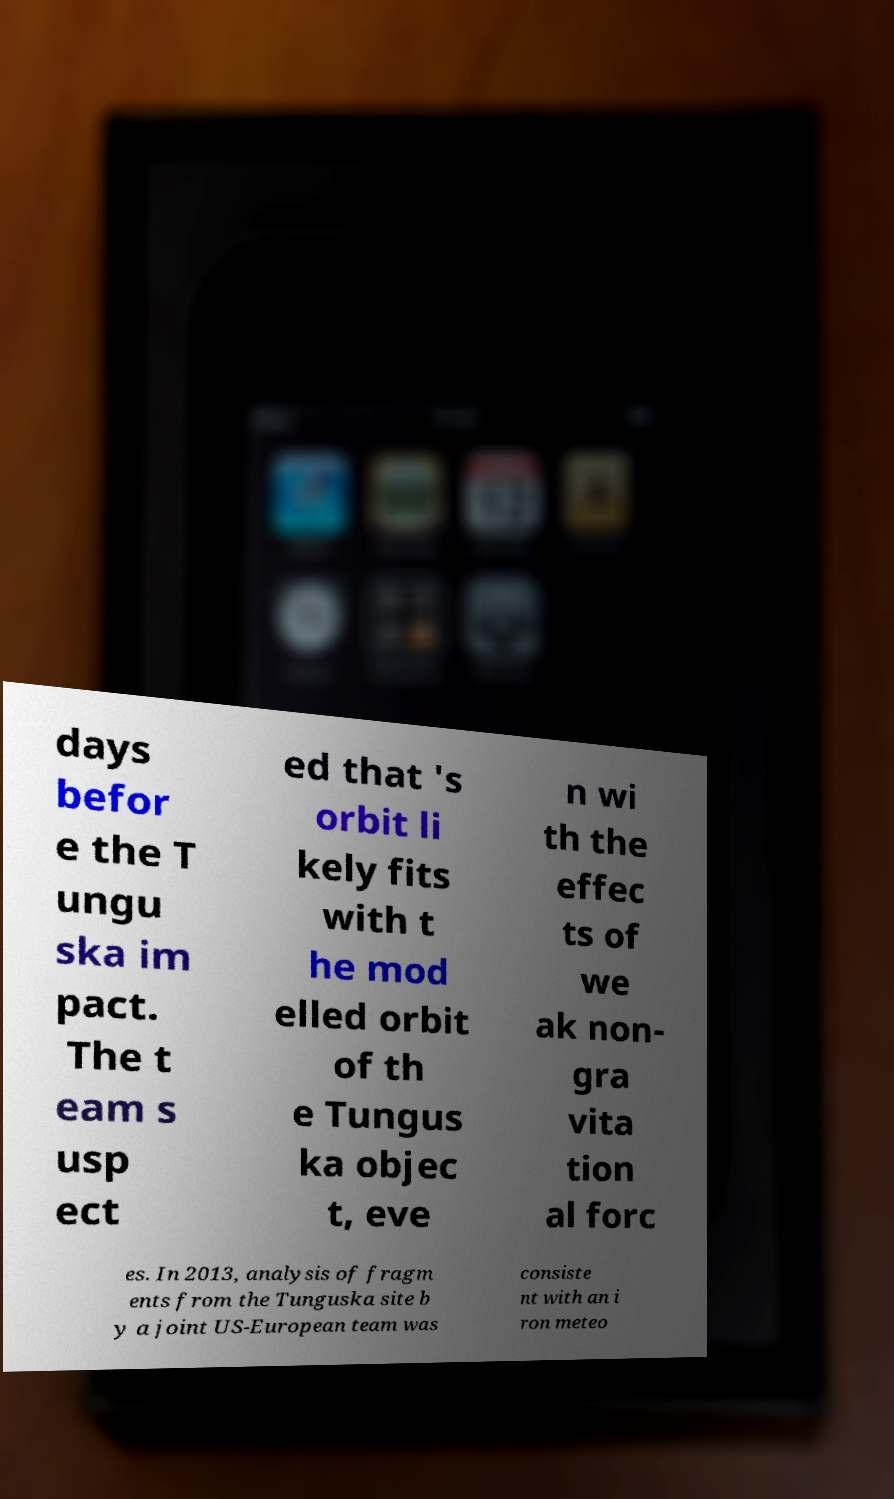Could you extract and type out the text from this image? days befor e the T ungu ska im pact. The t eam s usp ect ed that 's orbit li kely fits with t he mod elled orbit of th e Tungus ka objec t, eve n wi th the effec ts of we ak non- gra vita tion al forc es. In 2013, analysis of fragm ents from the Tunguska site b y a joint US-European team was consiste nt with an i ron meteo 